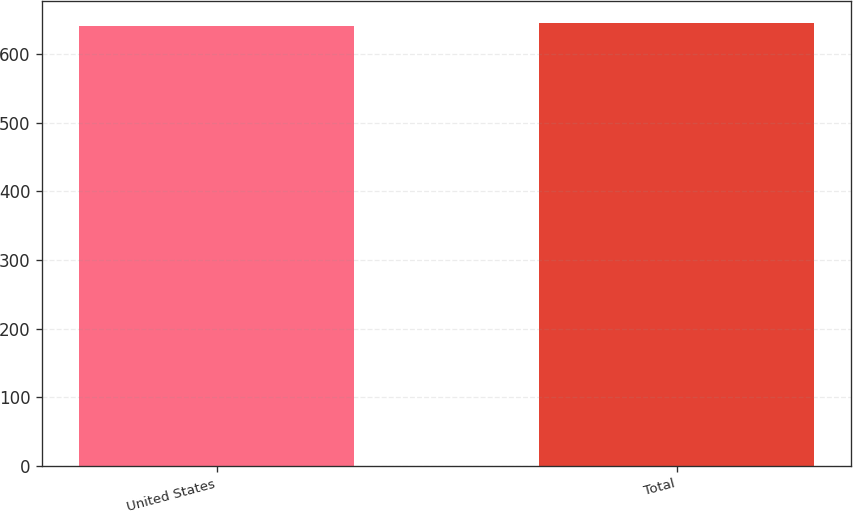<chart> <loc_0><loc_0><loc_500><loc_500><bar_chart><fcel>United States<fcel>Total<nl><fcel>641.2<fcel>644.6<nl></chart> 